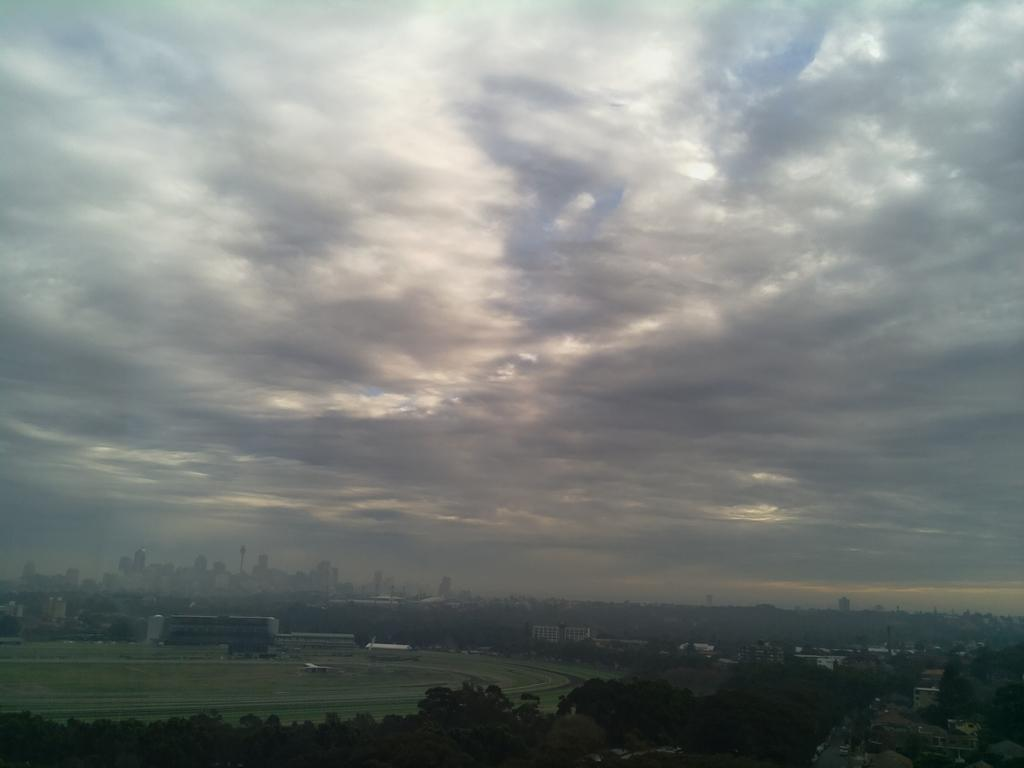What is located on the left side of the image? There is a ground on the left side of the image. What type of vegetation can be seen at the bottom of the image? There are trees at the bottom of the image. How would you describe the sky in the image? The sky is cloudy in the image. How many cars can be seen driving through the trees in the image? There are no cars present in the image; it features a ground and trees with a cloudy sky. What type of dinosaur might be expressing regret in the image? There are no dinosaurs present in the image, and therefore no such expression of regret can be observed. 